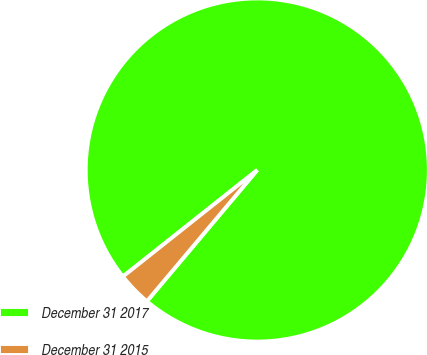Convert chart. <chart><loc_0><loc_0><loc_500><loc_500><pie_chart><fcel>December 31 2017<fcel>December 31 2015<nl><fcel>96.8%<fcel>3.2%<nl></chart> 